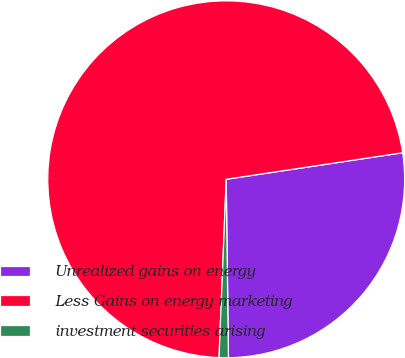Convert chart. <chart><loc_0><loc_0><loc_500><loc_500><pie_chart><fcel>Unrealized gains on energy<fcel>Less Gains on energy marketing<fcel>investment securities arising<nl><fcel>27.18%<fcel>71.99%<fcel>0.84%<nl></chart> 